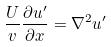Convert formula to latex. <formula><loc_0><loc_0><loc_500><loc_500>\frac { U } { v } \frac { \partial u ^ { \prime } } { \partial x } = \nabla ^ { 2 } u ^ { \prime }</formula> 